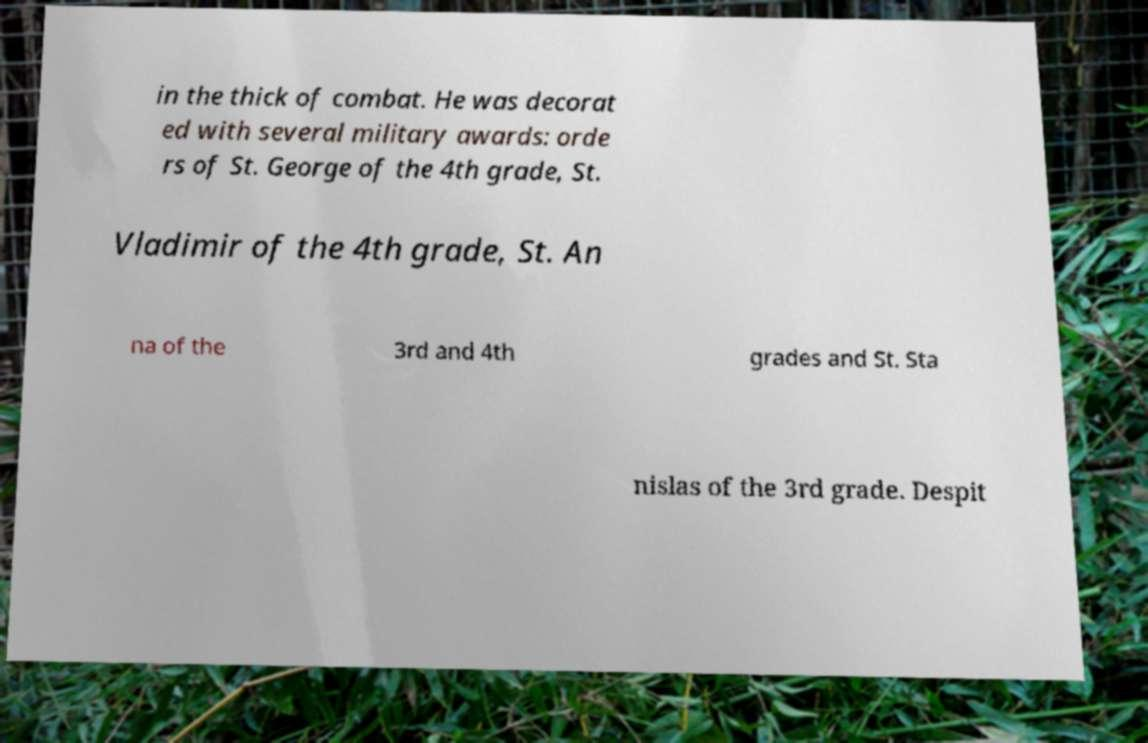Please identify and transcribe the text found in this image. in the thick of combat. He was decorat ed with several military awards: orde rs of St. George of the 4th grade, St. Vladimir of the 4th grade, St. An na of the 3rd and 4th grades and St. Sta nislas of the 3rd grade. Despit 